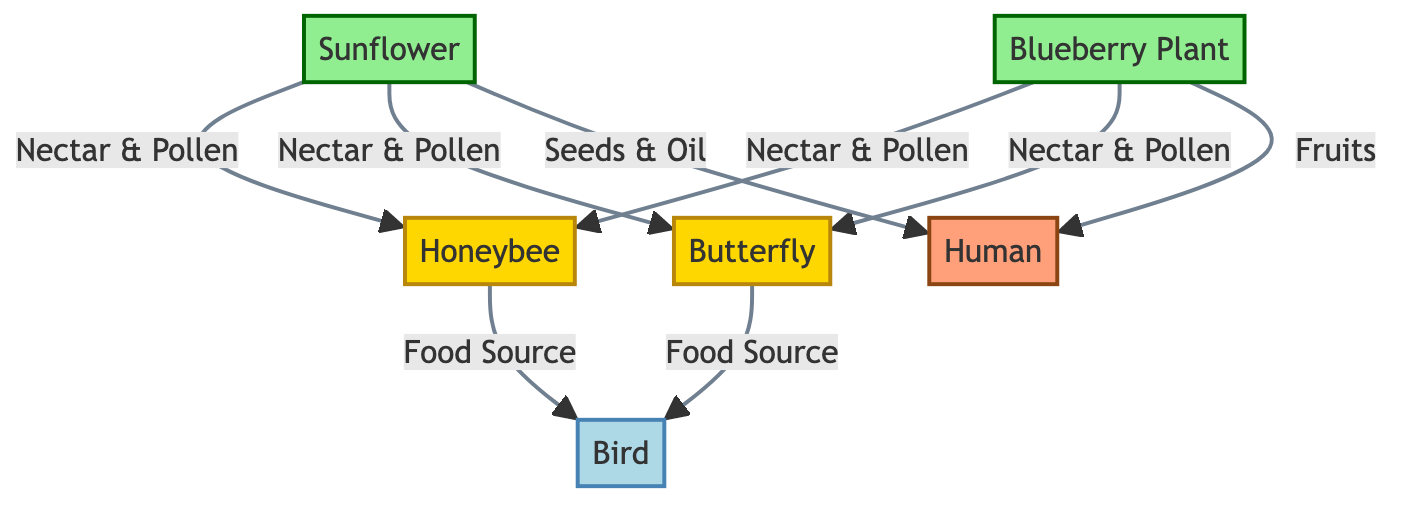What are the two plants shown in the diagram? The diagram lists two plants: Sunflower and Blueberry Plant. They are identified by the labels "A" and "B," which are both categorized under the "plant" class.
Answer: Sunflower, Blueberry Plant How many types of insects are present in the food chain? The diagram includes two types of insects: Honeybee and Butterfly. They are represented as nodes "C" and "D" in the diagram.
Answer: 2 Who benefits directly from the nectar and pollen of both plants? The Honeybee and Butterfly feed on the nectar and pollen supplied by both the Sunflower and Blueberry Plant. This relationship is illustrated with arrows pointing from the plants (A and B) to the insects (C and D).
Answer: Honeybee, Butterfly Which animal is a food source for the birds in this food chain? The Honeybee and Butterfly are the food sources for the Bird, as indicated by the arrows leading from the insects (C and D) to the animal (E).
Answer: Honeybee, Butterfly What do humans receive from Blueberry Plants and Sunflowers? Humans obtain fruits from the Blueberry Plant and seeds & oil from the Sunflower, as shown by the arrows pointing from the plants (A and B) to the human node (F).
Answer: Fruits, Seeds & Oil How many edges are connected to the Blueberry Plant? The Blueberry Plant has three edges connected to it: one to the Honeybee, one to the Butterfly, and one to the Human for its fruits. The edges represent the relationships between the nodes, confirming the connections of the Blueberry Plant.
Answer: 3 Which node represents the primary insect pollinator in this food chain? The Honeybee is often considered the primary insect pollinator in many agricultural contexts, as it plays a crucial role in pollinating flowers for fruit production and is denoted as node "C."
Answer: Honeybee How many total nodes are represented in the food chain? The diagram shows a total of six nodes: two plants, two insects, one animal, and one human, totaling to six distinct entities within the food chain structure.
Answer: 6 What is the primary role of pollinators in this food chain? Pollinators such as the Honeybee and Butterfly facilitate the transfer of pollen from flowers, assisting in the reproduction of plants which ultimately leads to the production of fruits and seeds that humans and birds rely on.
Answer: Pollination 